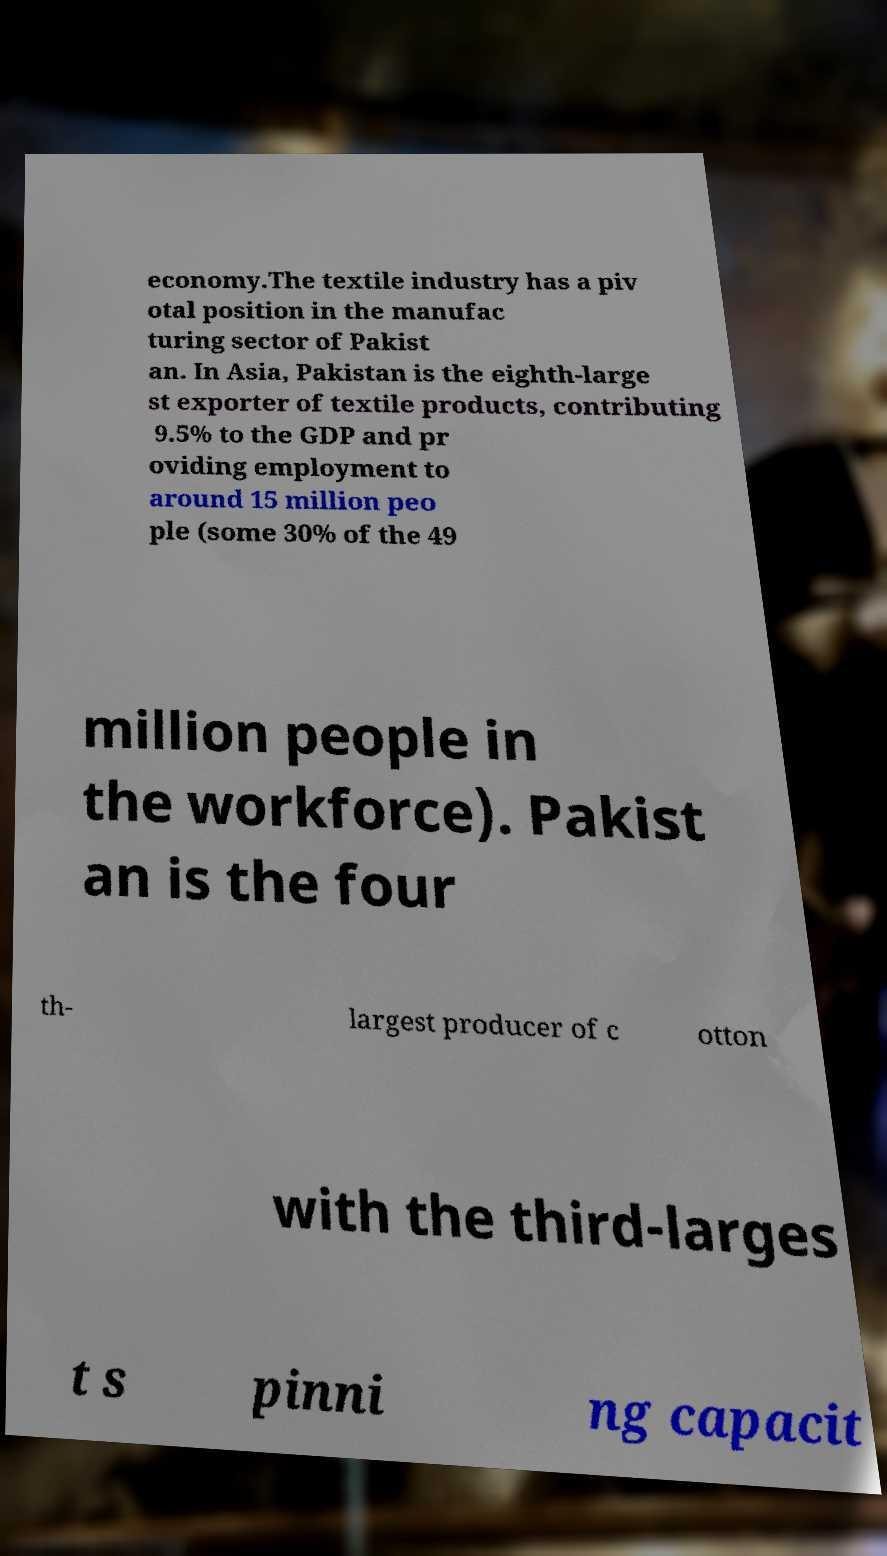Please identify and transcribe the text found in this image. economy.The textile industry has a piv otal position in the manufac turing sector of Pakist an. In Asia, Pakistan is the eighth-large st exporter of textile products, contributing 9.5% to the GDP and pr oviding employment to around 15 million peo ple (some 30% of the 49 million people in the workforce). Pakist an is the four th- largest producer of c otton with the third-larges t s pinni ng capacit 